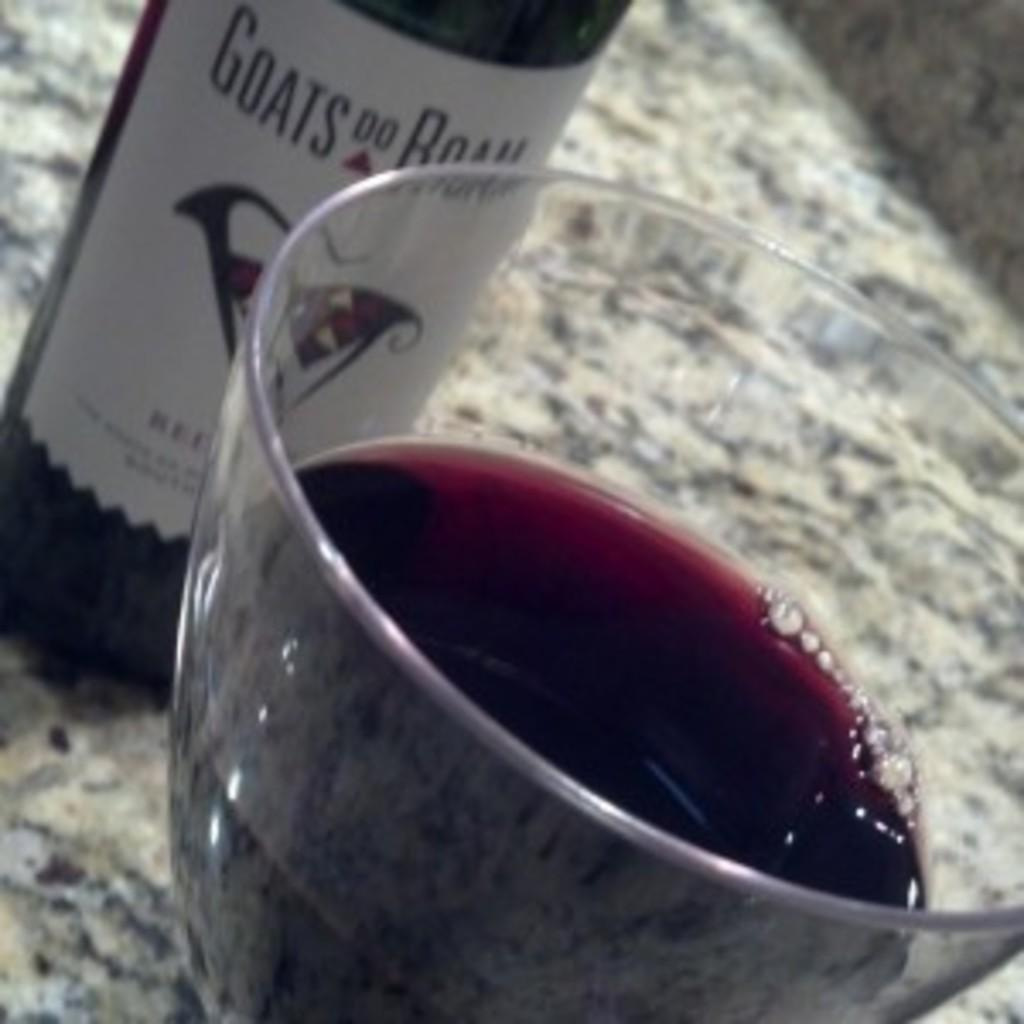<image>
Relay a brief, clear account of the picture shown. A wine bottle called goats do roam in red. 